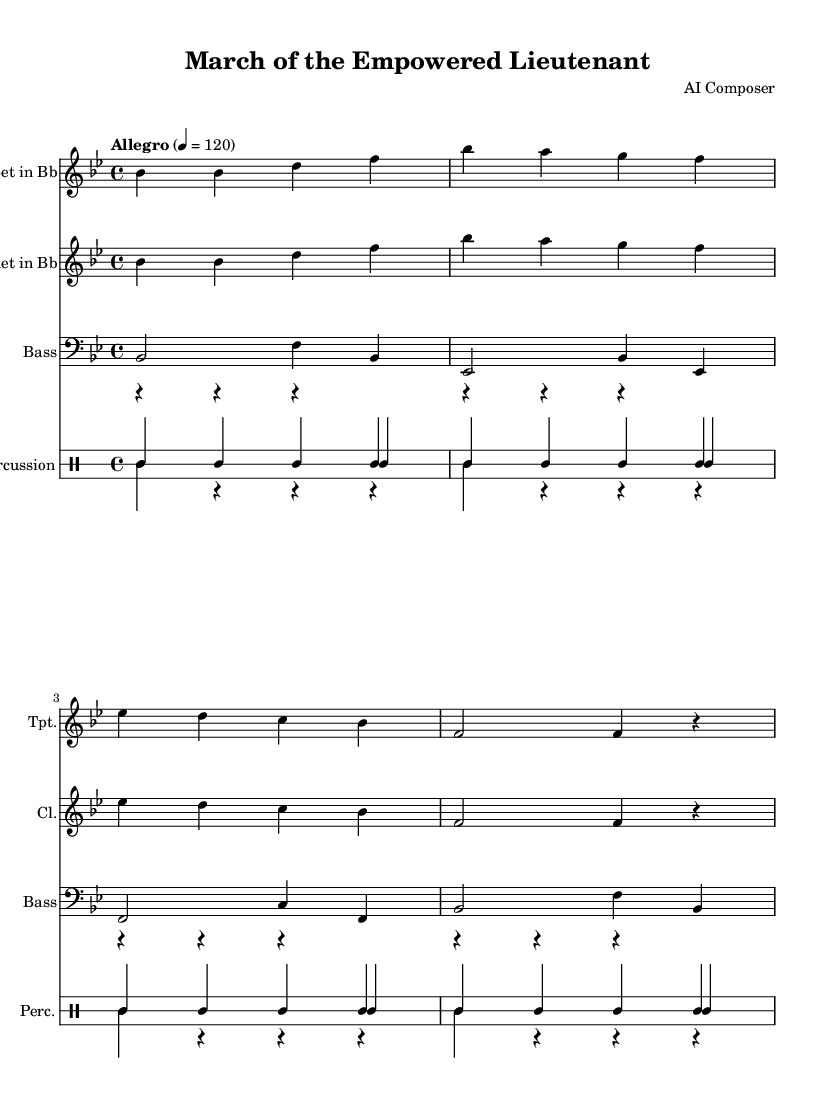what is the key signature of this music? The key signature is B-flat major, which has two flats (B-flat and E-flat). This can be identified at the beginning of the sheet music, where the key signature is notated.
Answer: B-flat major what is the time signature of this music? The time signature is 4/4, indicated at the beginning of the music. This means there are four beats in each measure, and a quarter note gets one beat.
Answer: 4/4 what is the tempo marking for this piece? The tempo marking at the top specifies "Allegro," indicating a fast and lively tempo. The actual metronome marking of 120 beats per minute confirms this.
Answer: Allegro how many different instruments are present in this composition? There are four different instruments indicated in the score: Trumpet in Bb, Clarinet in Bb, Bass, and Percussion, which includes snare, bass drum, and cymbals. This can be seen from the separate staves for each instrument.
Answer: Four what is the rhythm pattern of the snare drum in the first four measures? The rhythm pattern for the snare drum consists of a series of quarter notes played in each measure, which can be seen in the drum staff notation. There are four snare hits in each measure during the first four measures.
Answer: Four quarter notes what phrase in the score establishes the emotion of camaraderie? The repeated melody played by the Trumpet and Clarinet throughout the march signifies a feeling of unity and celebration. Both instruments echo similar thematic material, which creates an atmosphere of camaraderie among the musicians.
Answer: The repeated melody what is the final measure's note duration in the bass line? The final measure of the bass line consists of two half notes followed by a quarter note then a rest, indicating the conclusion of the piece. This can be seen by examining the last measure closely for the note values.
Answer: Two half notes and one quarter note 